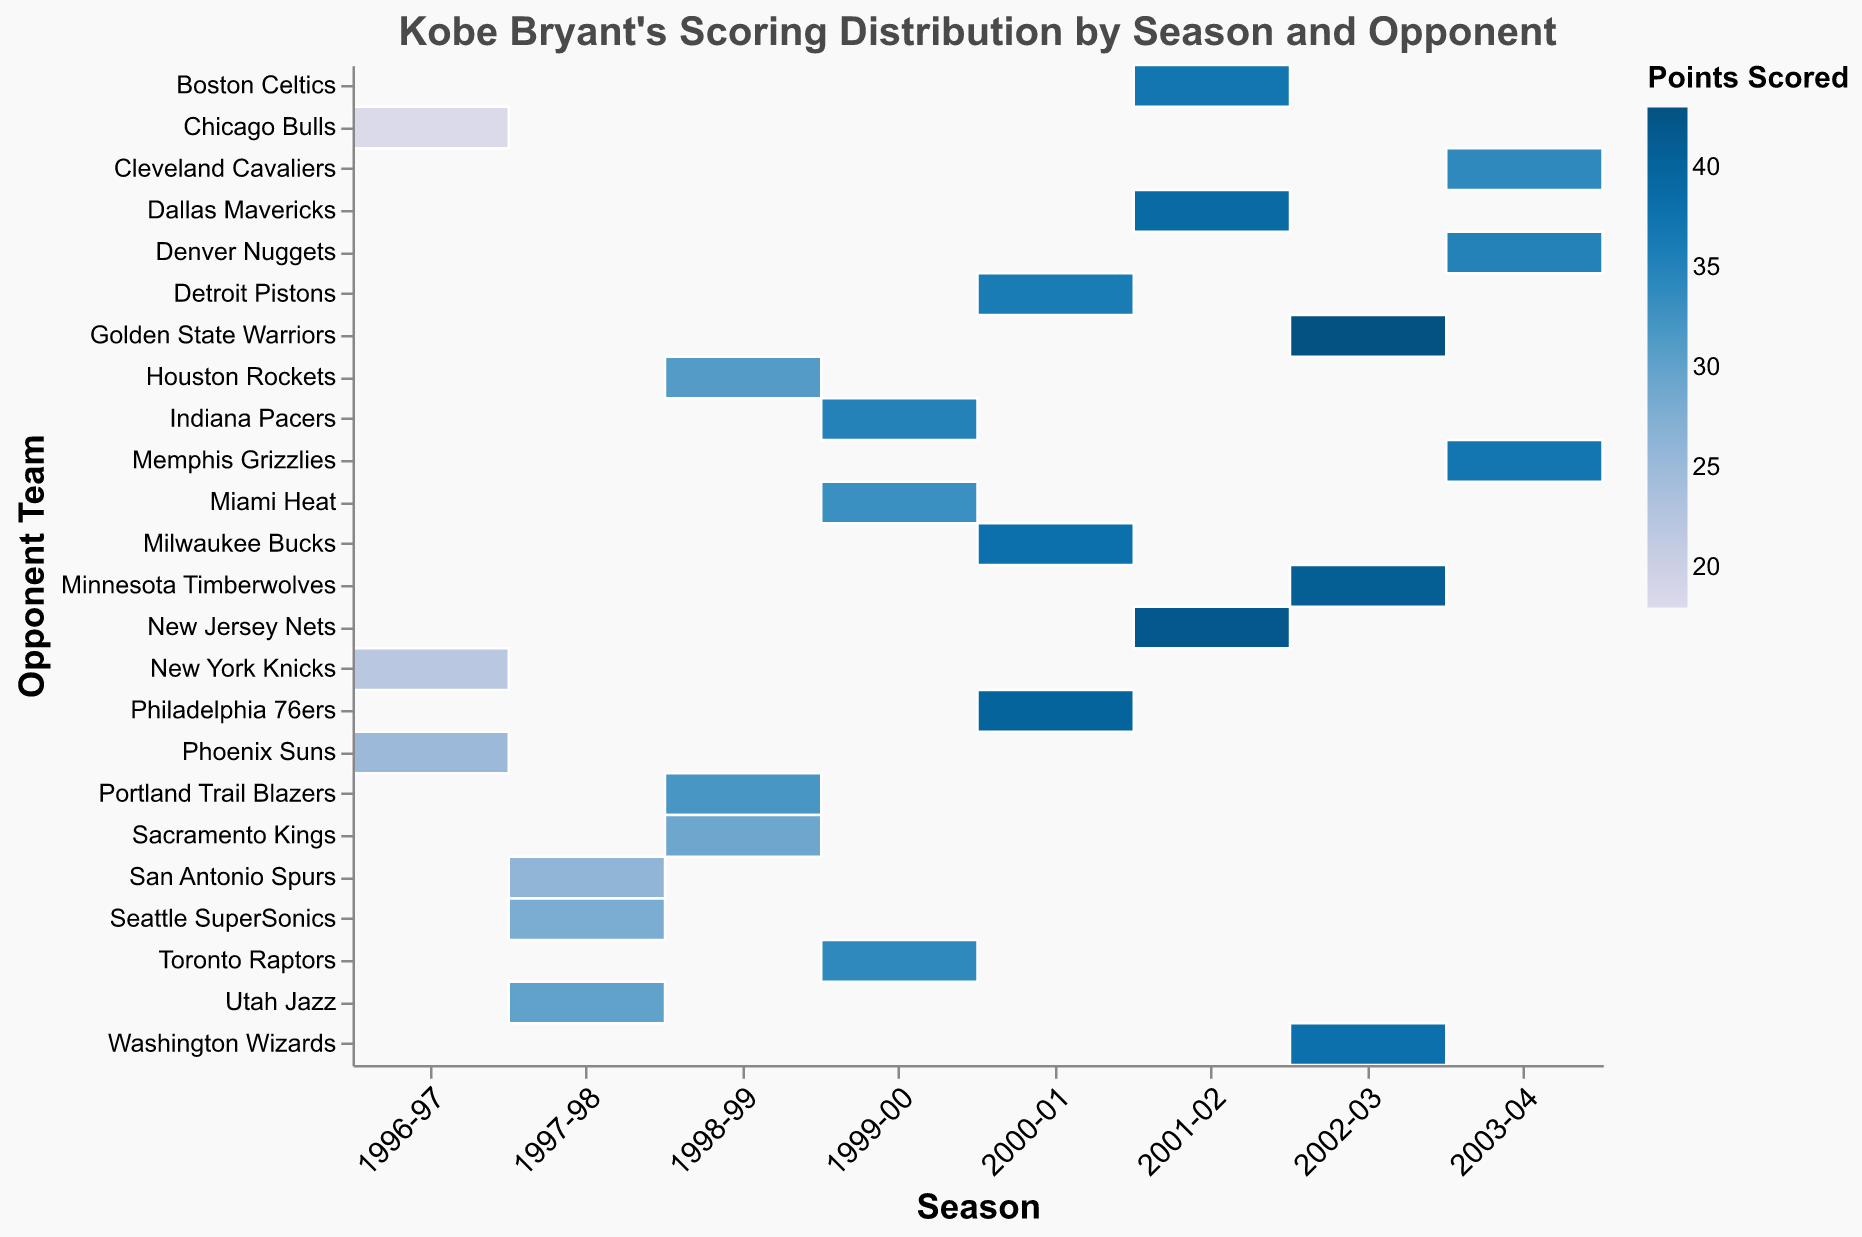What is the title of the plot? The title of the plot is displayed at the top and provides information about what the plot is visualizing.
Answer: Kobe Bryant's Scoring Distribution by Season and Opponent Which season has the most varied scores based on the color distribution? A varied score distribution would show a mix of many different colors. The 2002-03 season has a broad range of colors, indicating varied scoring.
Answer: 2002-03 Which team did Kobe Bryant score the most points against in the 1999-00 season? Look for the darkest color box in the 1999-00 season column; it corresponds to the highest points scored.
Answer: Indiana Pacers In which season did Kobe score against the Phoenix Suns, and how many points did he score? Look for the "Phoenix Suns" row and identify the "Season" column it aligns with.
Answer: 1996-97, 25 points How does Kobe's scoring in the 2001-02 season compare to the 1996-97 season? Compare the color intensity across the two seasons. The darker the color, the higher the score. 2001-02 season has overall darker colors.
Answer: Higher in 2001-02 What is the range of points scored by Kobe Bryant against the teams in the 2003-04 season? Identify the minimum and maximum points by looking at the color scale in the 2003-04 season column.
Answer: 34-37 points Against which team did Kobe score the highest points in the given data? Find the darkest color cell across all seasons; it corresponds to the highest points scored.
Answer: Golden State Warriors How many points did Kobe score against the Boston Celtics in the 2001-02 season? Look for the "Boston Celtics" row within the 2001-02 season column and find the corresponding color.
Answer: 37 points What pattern can be observed in Kobe's scoring trend over the seasons? Analyze the color intensity from season to season; look for trends like increasing or decreasing score ranges. Kobe's scoring shows an upward trend over the years with some variations.
Answer: Increasing with variations Which team has Kobe scored close scores against in different seasons? Look for a team where the color shades are similar in multiple seasons. For example, the scores against the Cleveland Cavaliers are close in 2003-04 and Miami Heat in 1999-00.
Answer: Cavaliers and Heat 